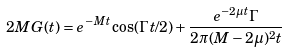Convert formula to latex. <formula><loc_0><loc_0><loc_500><loc_500>2 M G ( t ) = e ^ { - M t } \cos ( \Gamma t / 2 ) + \frac { e ^ { - 2 \mu t } \Gamma } { 2 \pi ( M - 2 \mu ) ^ { 2 } t }</formula> 